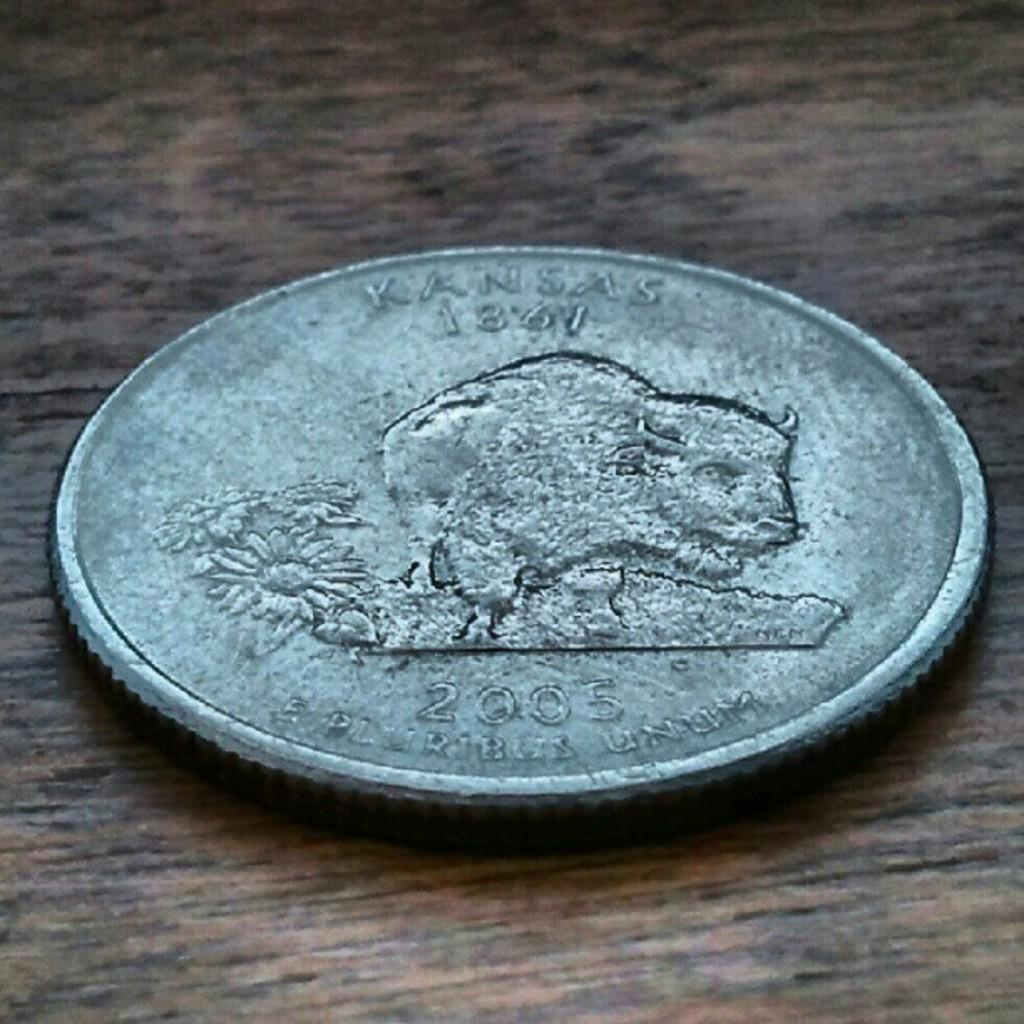<image>
Describe the image concisely. A coin from 2005 with a buffalo on it that also says Kansas. 